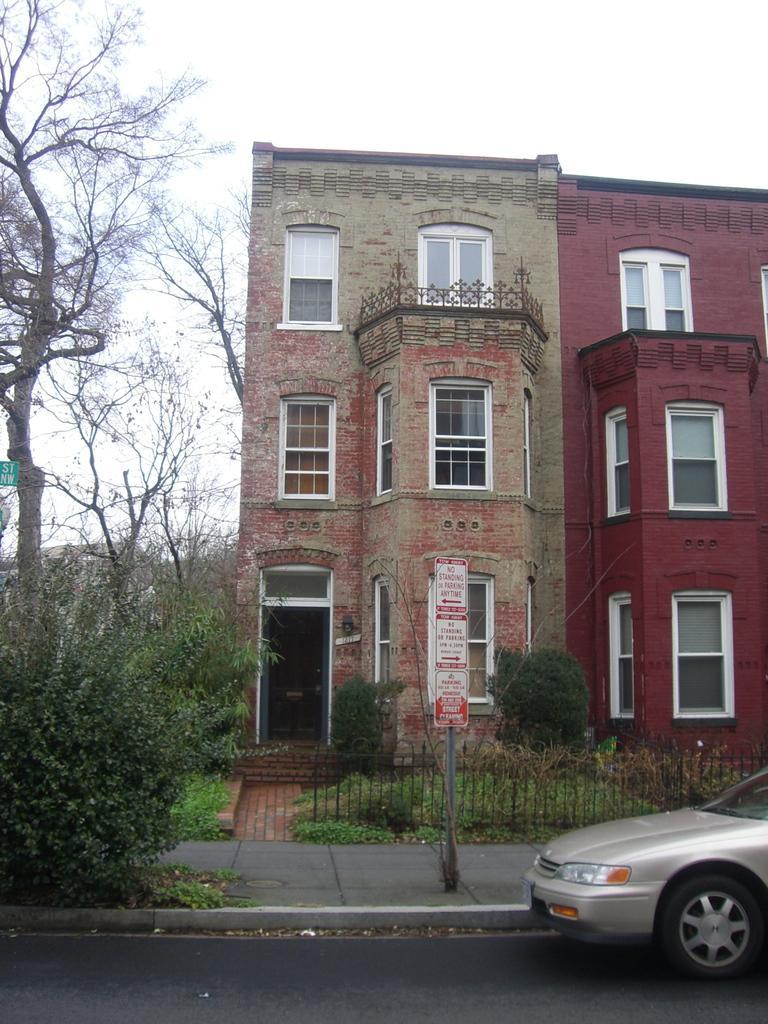Please provide a concise description of this image. At the bottom of the image there is a road with car. Behind the road there is a footpath. On the footpath there is a pole with sign board and also there are trees. And also there is a fencing. In the background there is a building with walls, windows, balcony and door. In front of the building there are trees and grass on the ground. At the top of the image there is a sky. 